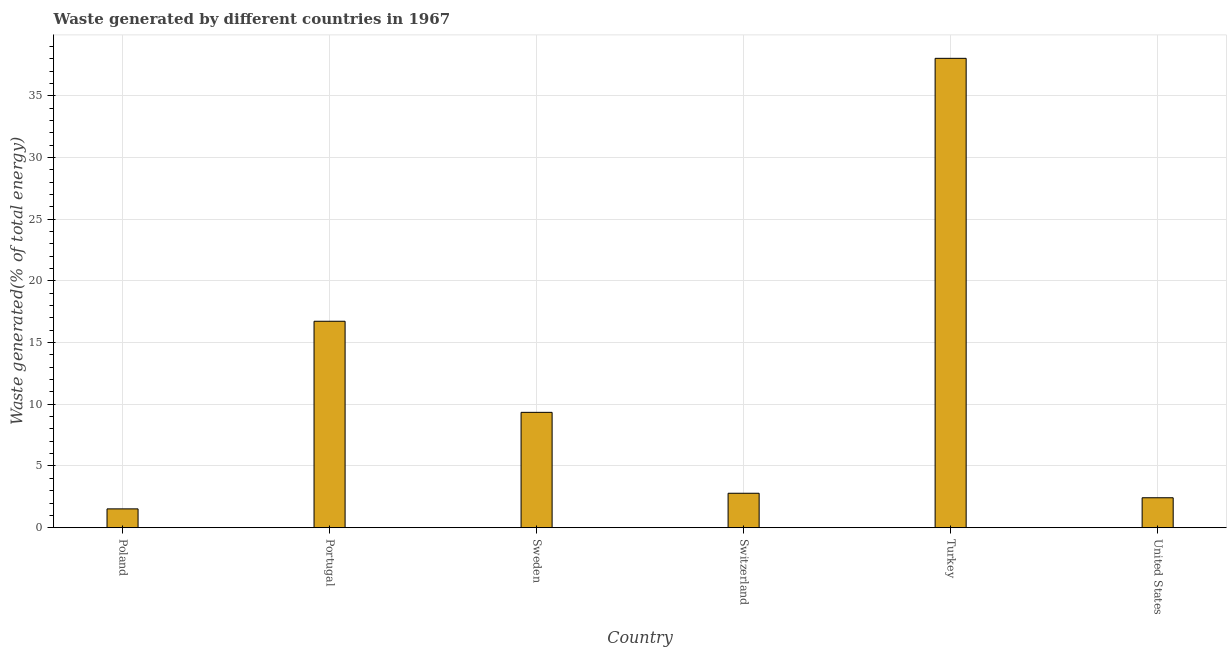What is the title of the graph?
Provide a short and direct response. Waste generated by different countries in 1967. What is the label or title of the X-axis?
Provide a short and direct response. Country. What is the label or title of the Y-axis?
Keep it short and to the point. Waste generated(% of total energy). What is the amount of waste generated in Sweden?
Keep it short and to the point. 9.35. Across all countries, what is the maximum amount of waste generated?
Give a very brief answer. 38.03. Across all countries, what is the minimum amount of waste generated?
Offer a terse response. 1.53. What is the sum of the amount of waste generated?
Offer a terse response. 70.84. What is the difference between the amount of waste generated in Poland and Switzerland?
Offer a very short reply. -1.26. What is the average amount of waste generated per country?
Provide a succinct answer. 11.81. What is the median amount of waste generated?
Ensure brevity in your answer.  6.07. In how many countries, is the amount of waste generated greater than 29 %?
Provide a succinct answer. 1. What is the ratio of the amount of waste generated in Poland to that in Portugal?
Your answer should be very brief. 0.09. Is the difference between the amount of waste generated in Turkey and United States greater than the difference between any two countries?
Offer a terse response. No. What is the difference between the highest and the second highest amount of waste generated?
Your answer should be very brief. 21.3. Is the sum of the amount of waste generated in Switzerland and Turkey greater than the maximum amount of waste generated across all countries?
Keep it short and to the point. Yes. What is the difference between the highest and the lowest amount of waste generated?
Your answer should be compact. 36.5. In how many countries, is the amount of waste generated greater than the average amount of waste generated taken over all countries?
Your response must be concise. 2. How many bars are there?
Provide a succinct answer. 6. What is the difference between two consecutive major ticks on the Y-axis?
Provide a succinct answer. 5. Are the values on the major ticks of Y-axis written in scientific E-notation?
Ensure brevity in your answer.  No. What is the Waste generated(% of total energy) of Poland?
Keep it short and to the point. 1.53. What is the Waste generated(% of total energy) in Portugal?
Make the answer very short. 16.73. What is the Waste generated(% of total energy) in Sweden?
Offer a very short reply. 9.35. What is the Waste generated(% of total energy) in Switzerland?
Provide a succinct answer. 2.79. What is the Waste generated(% of total energy) in Turkey?
Give a very brief answer. 38.03. What is the Waste generated(% of total energy) in United States?
Your answer should be very brief. 2.43. What is the difference between the Waste generated(% of total energy) in Poland and Portugal?
Ensure brevity in your answer.  -15.2. What is the difference between the Waste generated(% of total energy) in Poland and Sweden?
Provide a succinct answer. -7.82. What is the difference between the Waste generated(% of total energy) in Poland and Switzerland?
Give a very brief answer. -1.27. What is the difference between the Waste generated(% of total energy) in Poland and Turkey?
Make the answer very short. -36.5. What is the difference between the Waste generated(% of total energy) in Poland and United States?
Offer a very short reply. -0.9. What is the difference between the Waste generated(% of total energy) in Portugal and Sweden?
Provide a succinct answer. 7.38. What is the difference between the Waste generated(% of total energy) in Portugal and Switzerland?
Your answer should be compact. 13.94. What is the difference between the Waste generated(% of total energy) in Portugal and Turkey?
Offer a very short reply. -21.3. What is the difference between the Waste generated(% of total energy) in Portugal and United States?
Your answer should be compact. 14.3. What is the difference between the Waste generated(% of total energy) in Sweden and Switzerland?
Give a very brief answer. 6.56. What is the difference between the Waste generated(% of total energy) in Sweden and Turkey?
Your answer should be compact. -28.68. What is the difference between the Waste generated(% of total energy) in Sweden and United States?
Keep it short and to the point. 6.92. What is the difference between the Waste generated(% of total energy) in Switzerland and Turkey?
Offer a terse response. -35.24. What is the difference between the Waste generated(% of total energy) in Switzerland and United States?
Offer a very short reply. 0.36. What is the difference between the Waste generated(% of total energy) in Turkey and United States?
Keep it short and to the point. 35.6. What is the ratio of the Waste generated(% of total energy) in Poland to that in Portugal?
Give a very brief answer. 0.09. What is the ratio of the Waste generated(% of total energy) in Poland to that in Sweden?
Provide a succinct answer. 0.16. What is the ratio of the Waste generated(% of total energy) in Poland to that in Switzerland?
Provide a short and direct response. 0.55. What is the ratio of the Waste generated(% of total energy) in Poland to that in United States?
Offer a terse response. 0.63. What is the ratio of the Waste generated(% of total energy) in Portugal to that in Sweden?
Ensure brevity in your answer.  1.79. What is the ratio of the Waste generated(% of total energy) in Portugal to that in Switzerland?
Keep it short and to the point. 5.99. What is the ratio of the Waste generated(% of total energy) in Portugal to that in Turkey?
Make the answer very short. 0.44. What is the ratio of the Waste generated(% of total energy) in Portugal to that in United States?
Provide a succinct answer. 6.89. What is the ratio of the Waste generated(% of total energy) in Sweden to that in Switzerland?
Your answer should be compact. 3.35. What is the ratio of the Waste generated(% of total energy) in Sweden to that in Turkey?
Offer a terse response. 0.25. What is the ratio of the Waste generated(% of total energy) in Sweden to that in United States?
Your answer should be compact. 3.85. What is the ratio of the Waste generated(% of total energy) in Switzerland to that in Turkey?
Ensure brevity in your answer.  0.07. What is the ratio of the Waste generated(% of total energy) in Switzerland to that in United States?
Your answer should be very brief. 1.15. What is the ratio of the Waste generated(% of total energy) in Turkey to that in United States?
Provide a short and direct response. 15.67. 